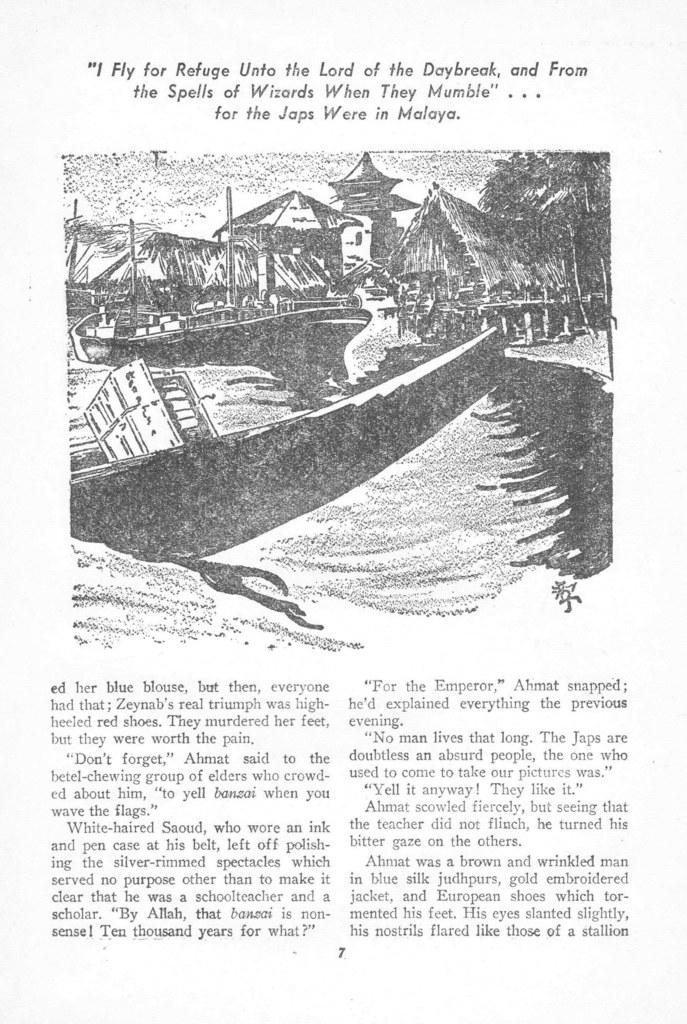What is the main subject of the image? The main subject of the image is an article. What is included within the article? There is a picture within the article. What can be seen in the picture? The picture contains houses, trees, poles, and other objects. What level of knowledge does the article provide about the shade of the trees? The image does not provide any information about the shade of the trees or the level of knowledge the article offers on the subject. 